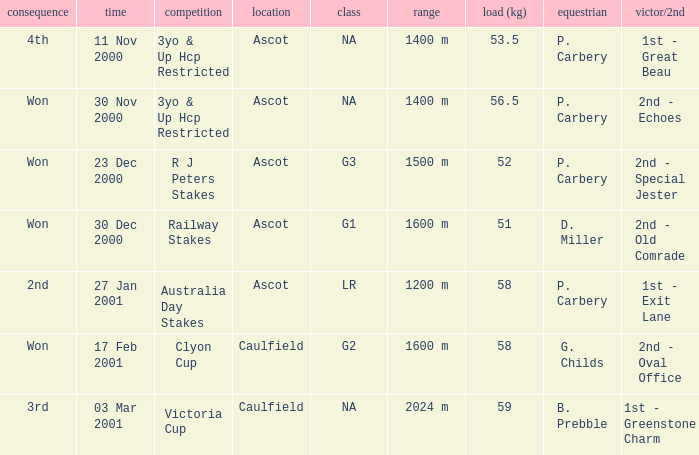What collective information can be found for the 5 NA. 